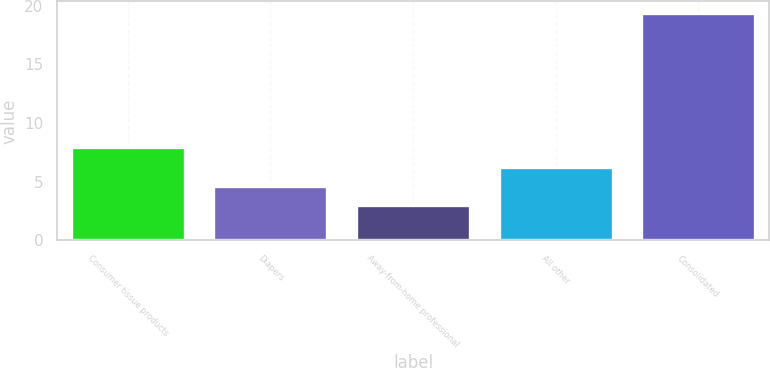Convert chart to OTSL. <chart><loc_0><loc_0><loc_500><loc_500><bar_chart><fcel>Consumer tissue products<fcel>Diapers<fcel>Away-from-home professional<fcel>All other<fcel>Consolidated<nl><fcel>7.92<fcel>4.64<fcel>3<fcel>6.28<fcel>19.4<nl></chart> 